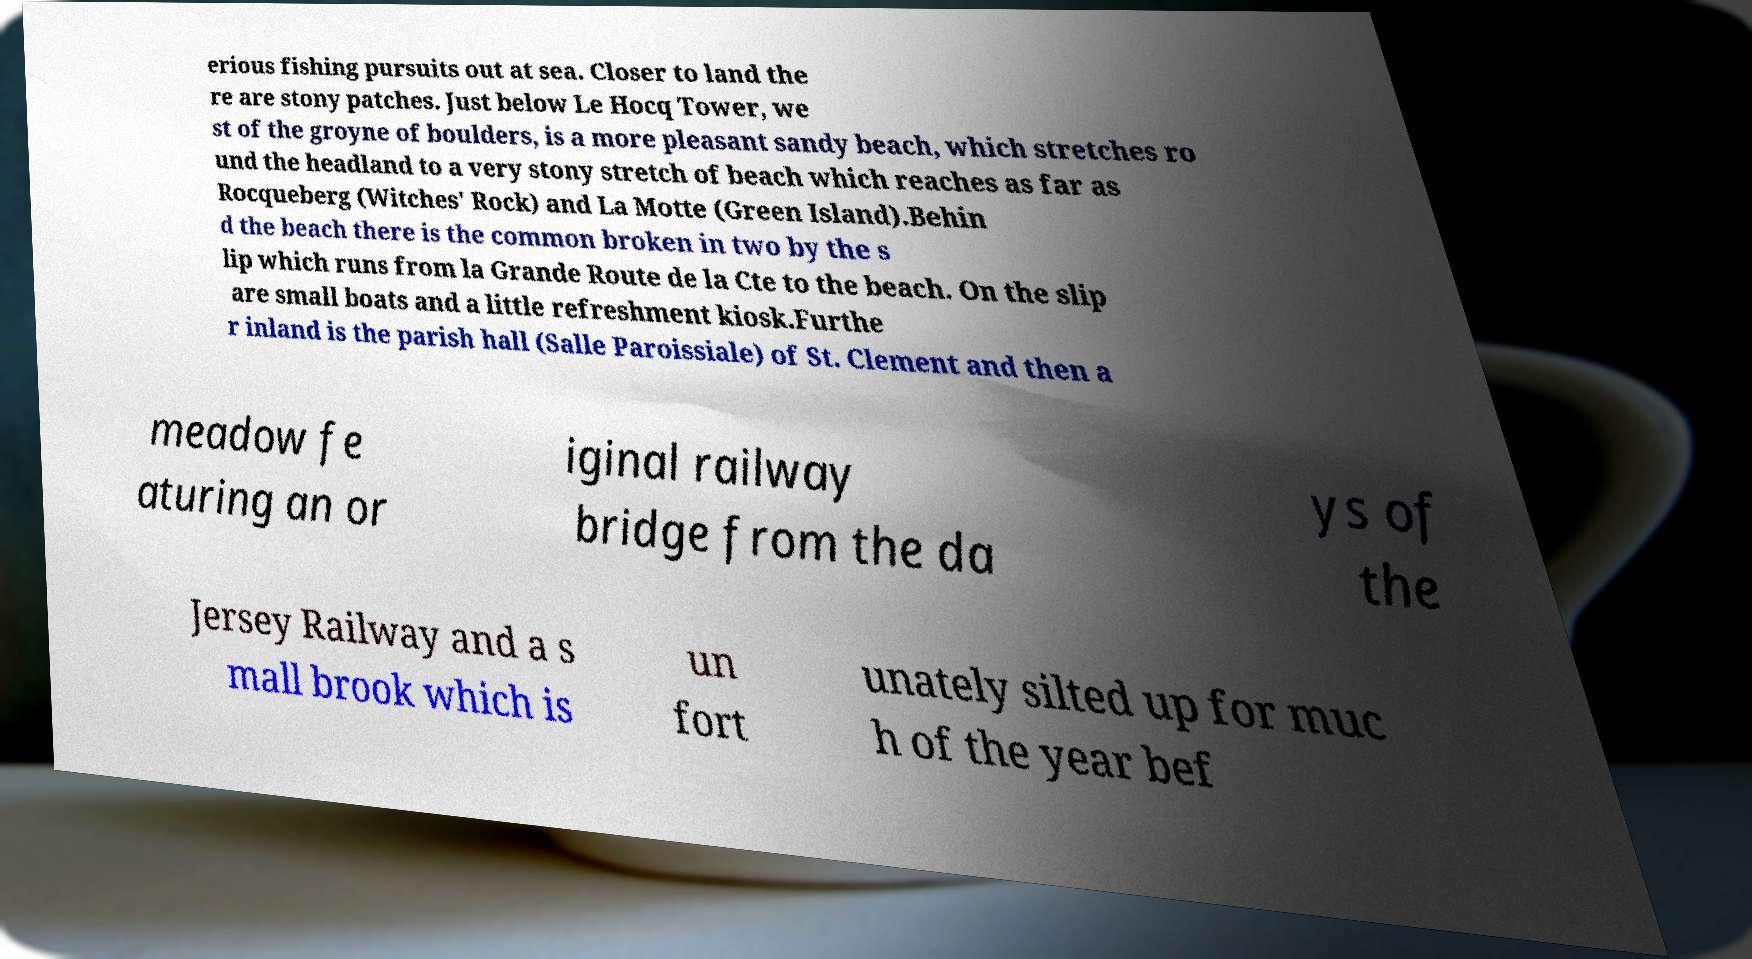Can you read and provide the text displayed in the image?This photo seems to have some interesting text. Can you extract and type it out for me? erious fishing pursuits out at sea. Closer to land the re are stony patches. Just below Le Hocq Tower, we st of the groyne of boulders, is a more pleasant sandy beach, which stretches ro und the headland to a very stony stretch of beach which reaches as far as Rocqueberg (Witches' Rock) and La Motte (Green Island).Behin d the beach there is the common broken in two by the s lip which runs from la Grande Route de la Cte to the beach. On the slip are small boats and a little refreshment kiosk.Furthe r inland is the parish hall (Salle Paroissiale) of St. Clement and then a meadow fe aturing an or iginal railway bridge from the da ys of the Jersey Railway and a s mall brook which is un fort unately silted up for muc h of the year bef 